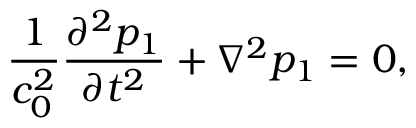<formula> <loc_0><loc_0><loc_500><loc_500>\frac { 1 } { c _ { 0 } ^ { 2 } } \frac { \partial ^ { 2 } p _ { 1 } } { \partial t ^ { 2 } } + \nabla ^ { 2 } p _ { 1 } = 0 ,</formula> 